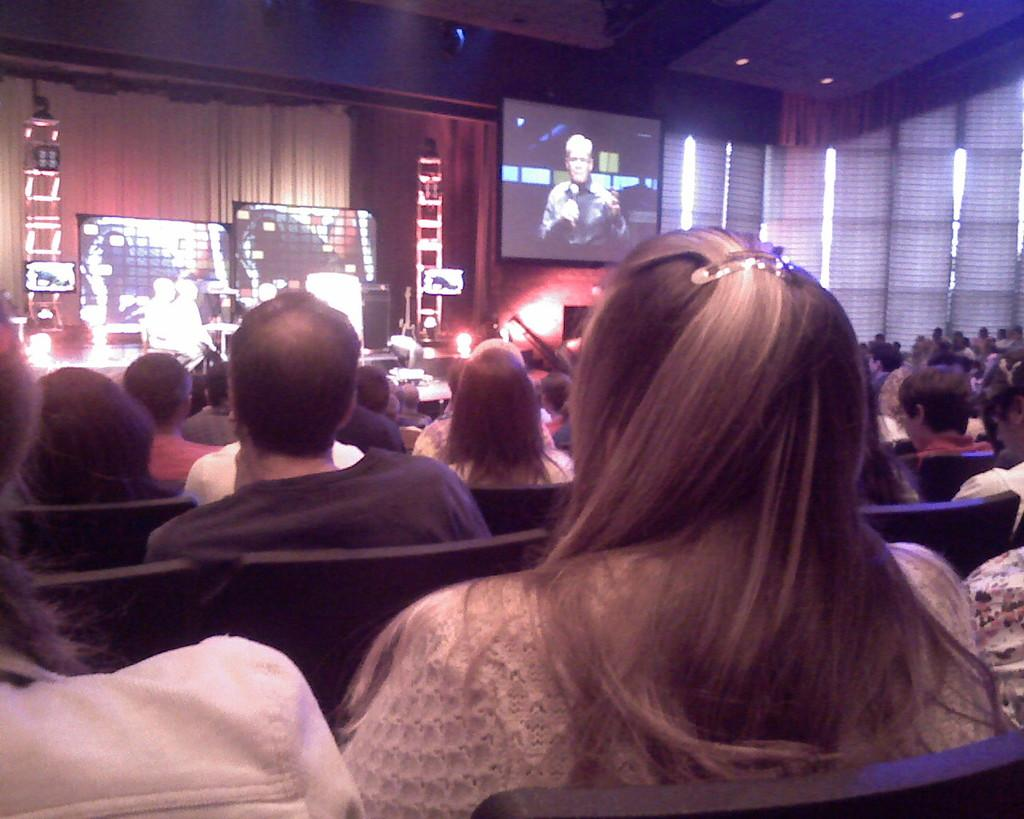What are the people in the image doing? The people in the image are sitting. What are the people wearing while sitting? The people are wearing clothes. How many chairs are visible in the image? There are many chairs in the image. What can be seen providing illumination in the image? There are lights visible in the image. What type of devices are present in the image? There are screens present in the image. What type of wax is being used to create the front of the cent in the image? There is no wax, front, or cent present in the image. 